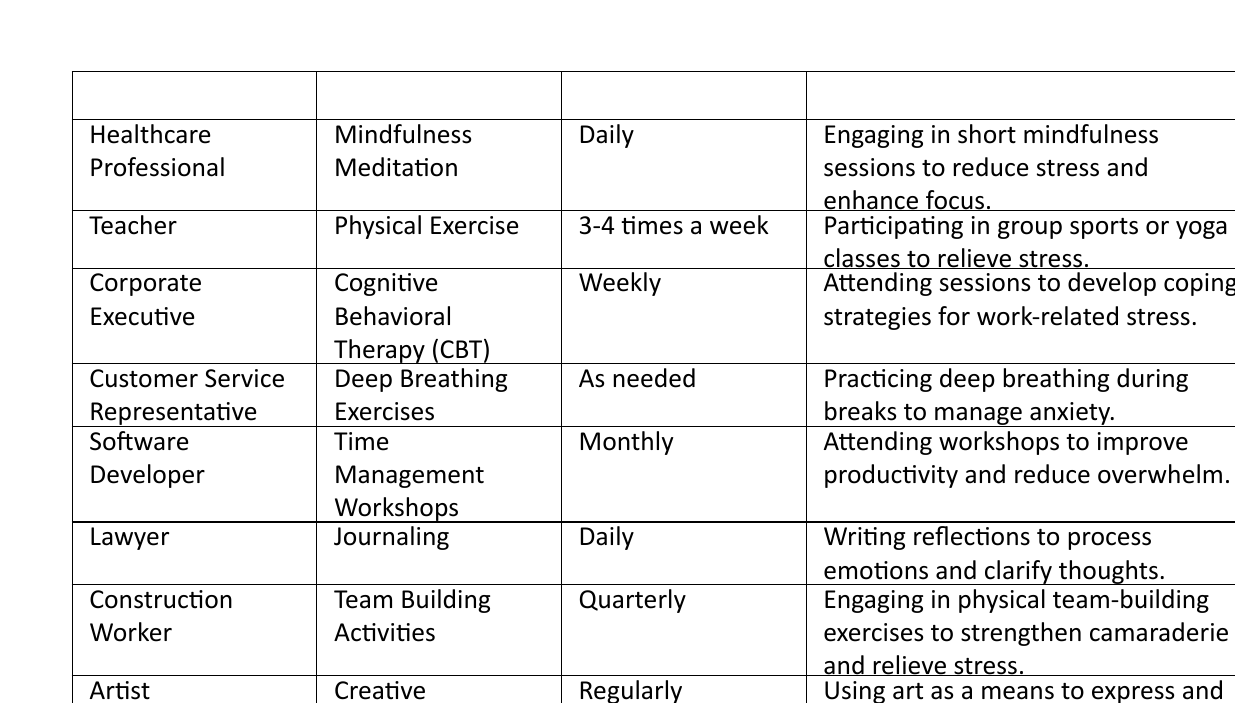What stress management technique do Healthcare Professionals use? The table shows that Healthcare Professionals utilize Mindfulness Meditation as their stress management technique.
Answer: Mindfulness Meditation How often do Teachers engage in Physical Exercise? According to the table, Teachers participate in Physical Exercise 3-4 times a week.
Answer: 3-4 times a week Is Deep Breathing Exercises used daily by Customer Service Representatives? The table indicates that Customer Service Representatives practice Deep Breathing Exercises "as needed," which does not mean daily.
Answer: No Which occupation utilizes Creative Expression as a stress management technique? The table lists the Artist as the occupation that uses Creative Expression regularly for stress management.
Answer: Artist What is the average frequency of stress management techniques for those who use daily or weekly practices? The frequencies for Daily are 1, and for Weekly are 1 (from Healthcare Professional and Corporate Executive respectively). We then average these: (1 (Daily) + 1 (Weekly)) = 2, and the average number of days considering "daily" counts as 1 per week and "weekly" as 1 gives us 2/2 = 1. Since Daily is 7 days a week: (7*1 + 1*1)/2 = 7/2 = 3.5
Answer: 3.5 What techniques does a Lawyer use for stress management? The table specifically states that Lawyers use Journaling for stress management, which is a daily practice.
Answer: Journaling 